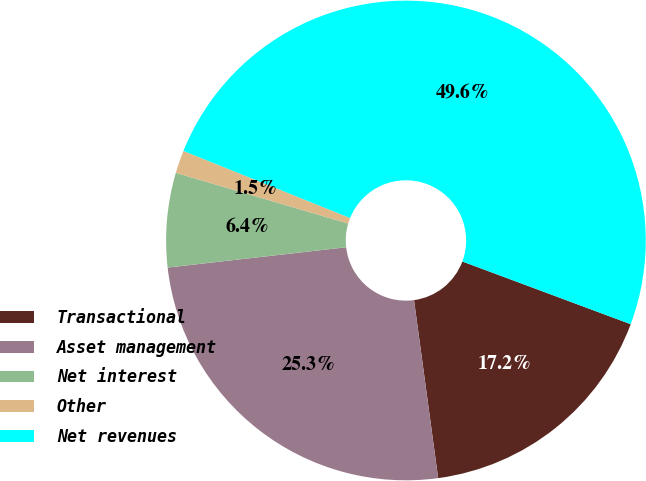<chart> <loc_0><loc_0><loc_500><loc_500><pie_chart><fcel>Transactional<fcel>Asset management<fcel>Net interest<fcel>Other<fcel>Net revenues<nl><fcel>17.18%<fcel>25.34%<fcel>6.35%<fcel>1.54%<fcel>49.58%<nl></chart> 